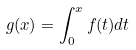<formula> <loc_0><loc_0><loc_500><loc_500>g ( x ) = \int _ { 0 } ^ { x } f ( t ) d t</formula> 